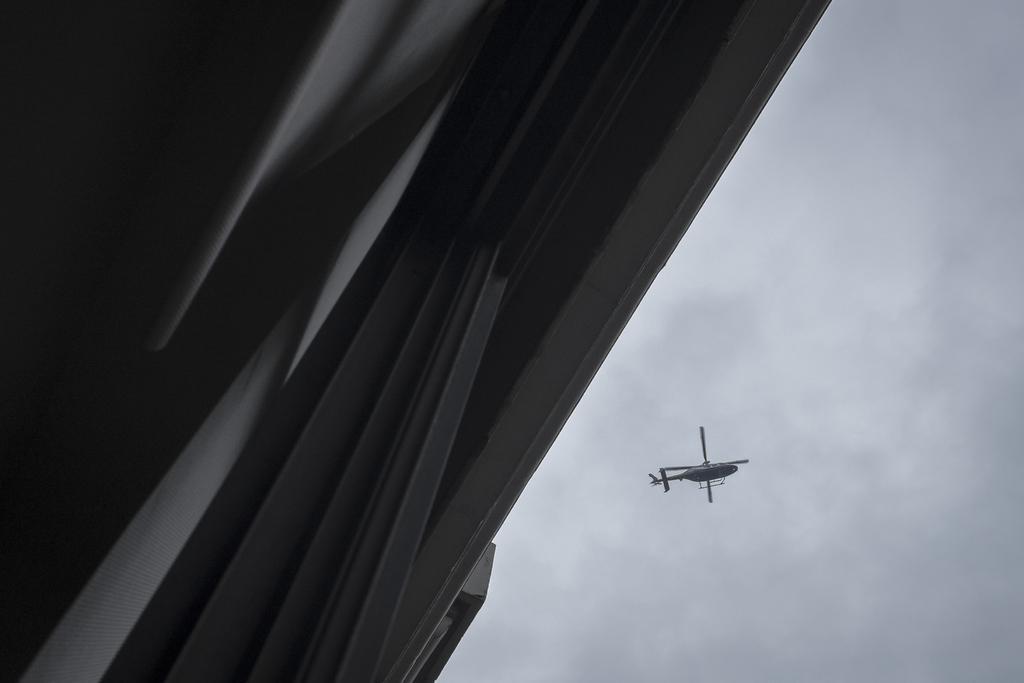Could you give a brief overview of what you see in this image? There is an helicopter flying in the sky and the picture is captured from the ground,in the background of the helicopter there is a dark sky. 